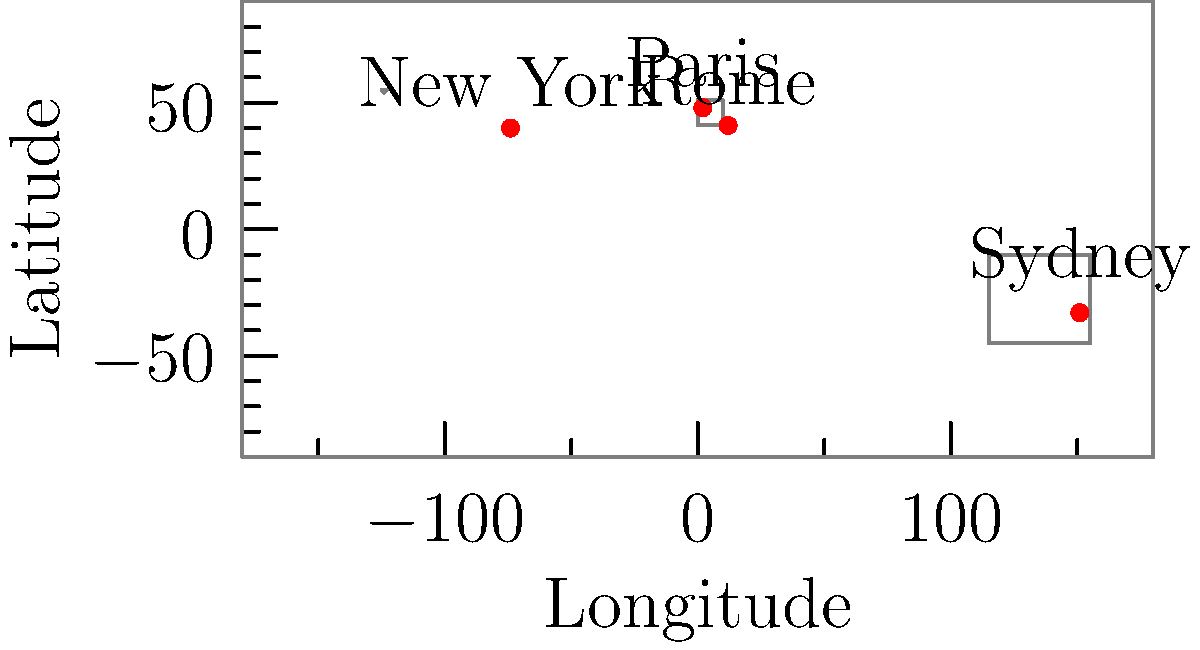Based on the world map showing David Bowie's concert locations, which city hosted a performance closest to the Prime Meridian (0° longitude)? To determine which city hosted a performance closest to the Prime Meridian (0° longitude), we need to follow these steps:

1. Identify the cities and their approximate coordinates:
   - New York: (-74°, 40°)
   - Paris: (2°, 48°)
   - Rome: (12°, 41°)
   - Sydney: (151°, -33°)

2. The Prime Meridian is at 0° longitude. We need to find which city's longitude is closest to 0°.

3. Calculate the absolute difference between each city's longitude and 0°:
   - New York: |(-74) - 0| = 74°
   - Paris: |2 - 0| = 2°
   - Rome: |12 - 0| = 12°
   - Sydney: |151 - 0| = 151°

4. The smallest difference indicates the city closest to the Prime Meridian.

5. Paris has the smallest difference of 2°, making it the closest to the Prime Meridian.

Therefore, Paris hosted the performance closest to the Prime Meridian.
Answer: Paris 